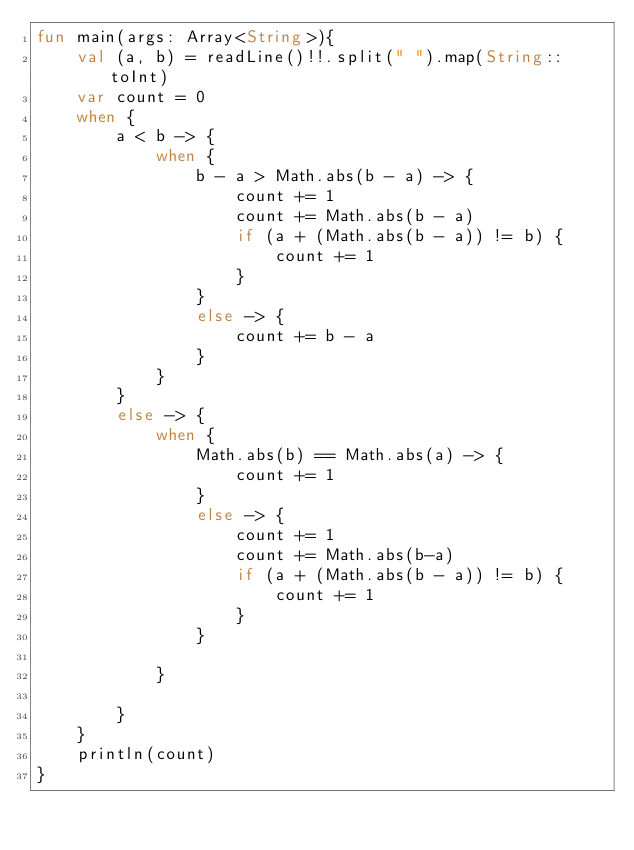<code> <loc_0><loc_0><loc_500><loc_500><_Kotlin_>fun main(args: Array<String>){
    val (a, b) = readLine()!!.split(" ").map(String::toInt)
    var count = 0
    when {
        a < b -> {
            when {
                b - a > Math.abs(b - a) -> {
                    count += 1
                    count += Math.abs(b - a)
                    if (a + (Math.abs(b - a)) != b) {
                        count += 1
                    }
                }
                else -> {
                    count += b - a
                }
            }
        }
        else -> {
            when {
                Math.abs(b) == Math.abs(a) -> {
                    count += 1
                }
                else -> {
                    count += 1
                    count += Math.abs(b-a)
                    if (a + (Math.abs(b - a)) != b) {
                        count += 1
                    }
                }
            
            }
            
        }
    }
    println(count)
}</code> 